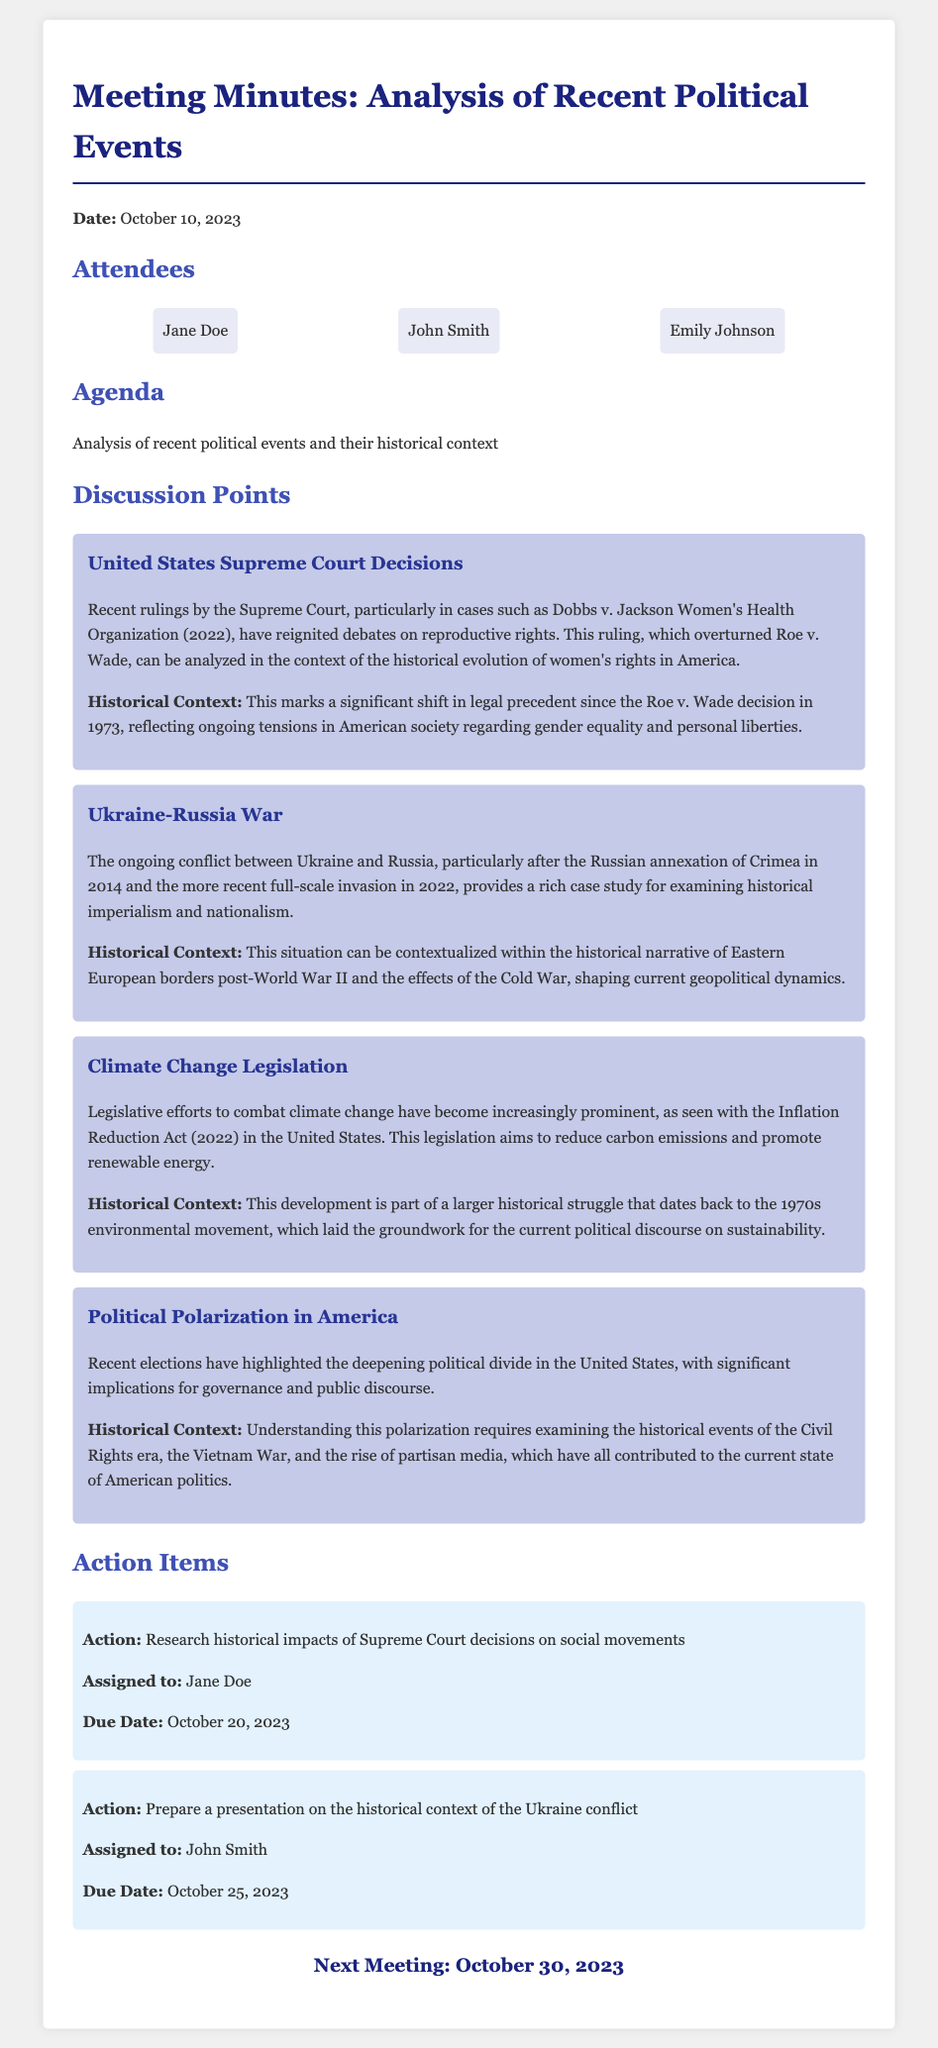What is the date of the meeting? The date of the meeting is specified in the document.
Answer: October 10, 2023 Who is assigned to research the historical impacts of Supreme Court decisions? The document lists action items and their assigned individuals.
Answer: Jane Doe What recent Supreme Court case is mentioned? The discussion point on Supreme Court decisions references a specific case.
Answer: Dobbs v. Jackson Women's Health Organization Which legislation aims to reduce carbon emissions? The document identifies a legislation focused on climate change efforts.
Answer: Inflation Reduction Act What is the next meeting's date? The document provides information about the scheduling of the next meeting.
Answer: October 30, 2023 How many attendees are listed in the meeting? The list of attendees is summarized in the attendees section.
Answer: Three What historical topic is linked to climate change legislation? A specific historical context is provided regarding the origins of climate change legislation efforts.
Answer: 1970s environmental movement Which attendee is responsible for preparing a presentation on the Ukraine conflict? The document assigns specific tasks to attendees for forthcoming actions.
Answer: John Smith What major theme is explored in the discussion of political polarization? The document links political polarization to significant historical events.
Answer: Civil Rights era 